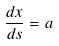Convert formula to latex. <formula><loc_0><loc_0><loc_500><loc_500>\frac { d x } { d s } = a</formula> 